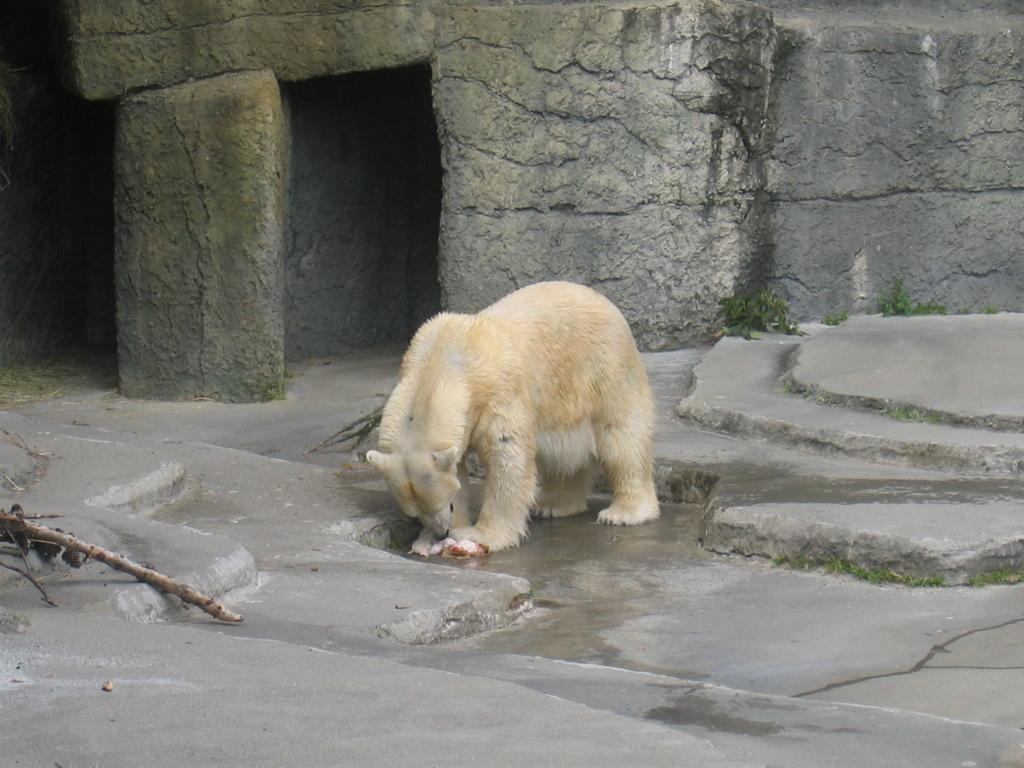What type of animal is in the image? There is a dog in the image. What is the dog's position in the image? The dog is standing on the ground. What can be seen in the background of the image? There is a wall and a branch of a tree in the background of the image. What type of toys does the dog have in the image? There are no toys visible in the image; it only features a dog standing on the ground with a wall and a branch of a tree in the background. 